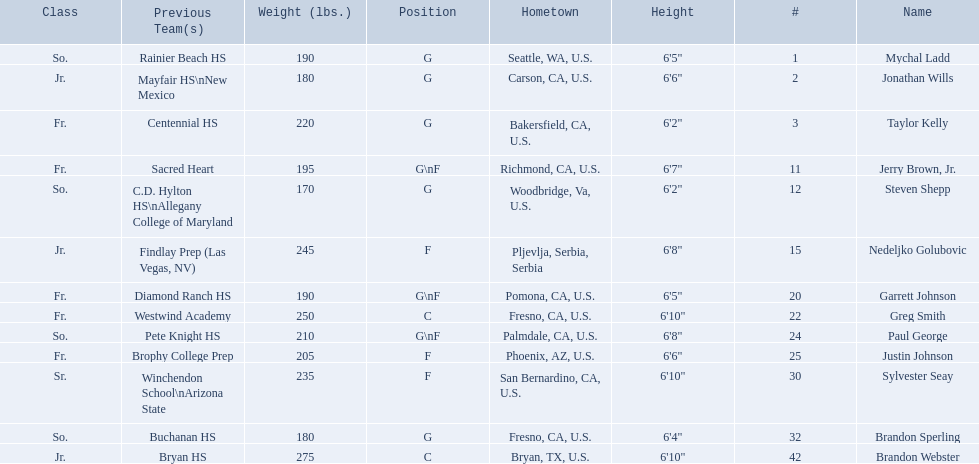What class was each team member in for the 2009-10 fresno state bulldogs? So., Jr., Fr., Fr., So., Jr., Fr., Fr., So., Fr., Sr., So., Jr. Which of these was outside of the us? Jr. Who was the player? Nedeljko Golubovic. Where were all of the players born? So., Jr., Fr., Fr., So., Jr., Fr., Fr., So., Fr., Sr., So., Jr. Who is the one from serbia? Nedeljko Golubovic. 